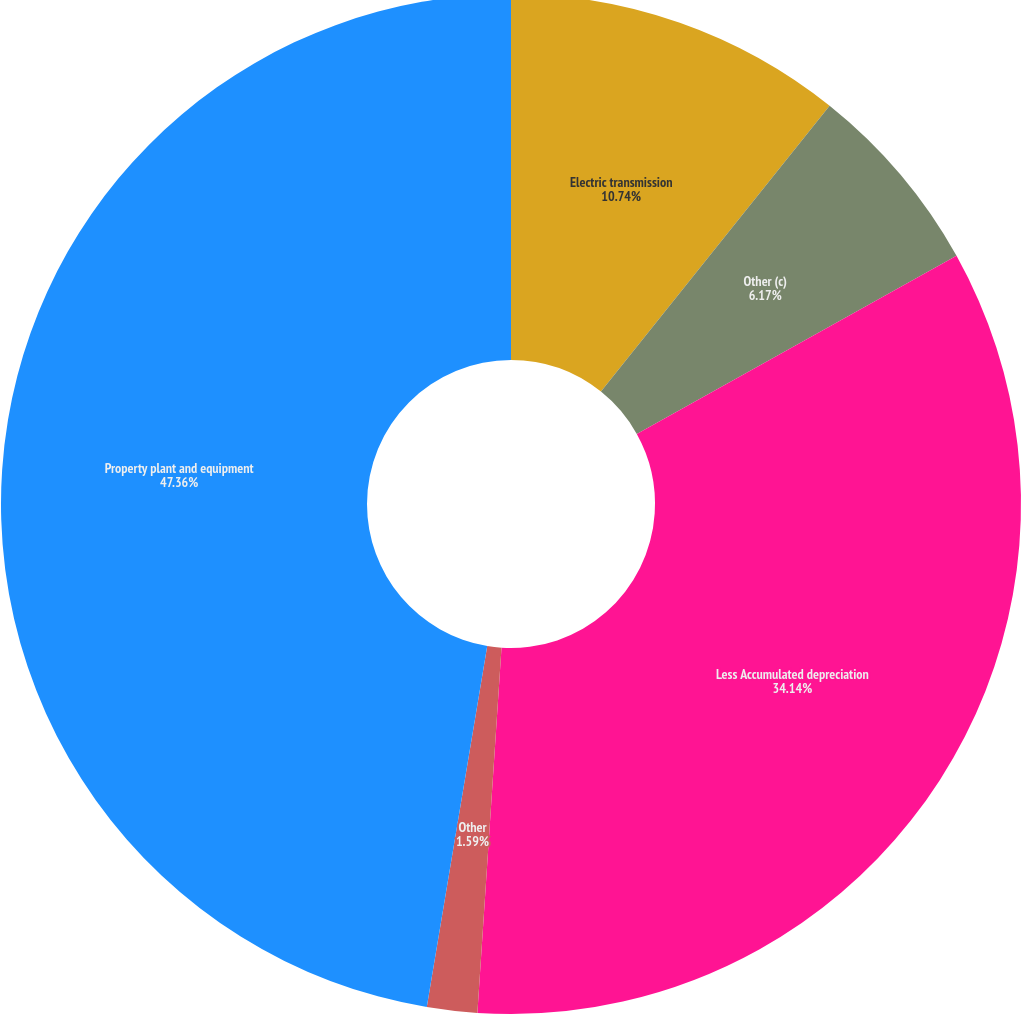Convert chart. <chart><loc_0><loc_0><loc_500><loc_500><pie_chart><fcel>Electric transmission<fcel>Other (c)<fcel>Less Accumulated depreciation<fcel>Other<fcel>Property plant and equipment<nl><fcel>10.74%<fcel>6.17%<fcel>34.14%<fcel>1.59%<fcel>47.36%<nl></chart> 